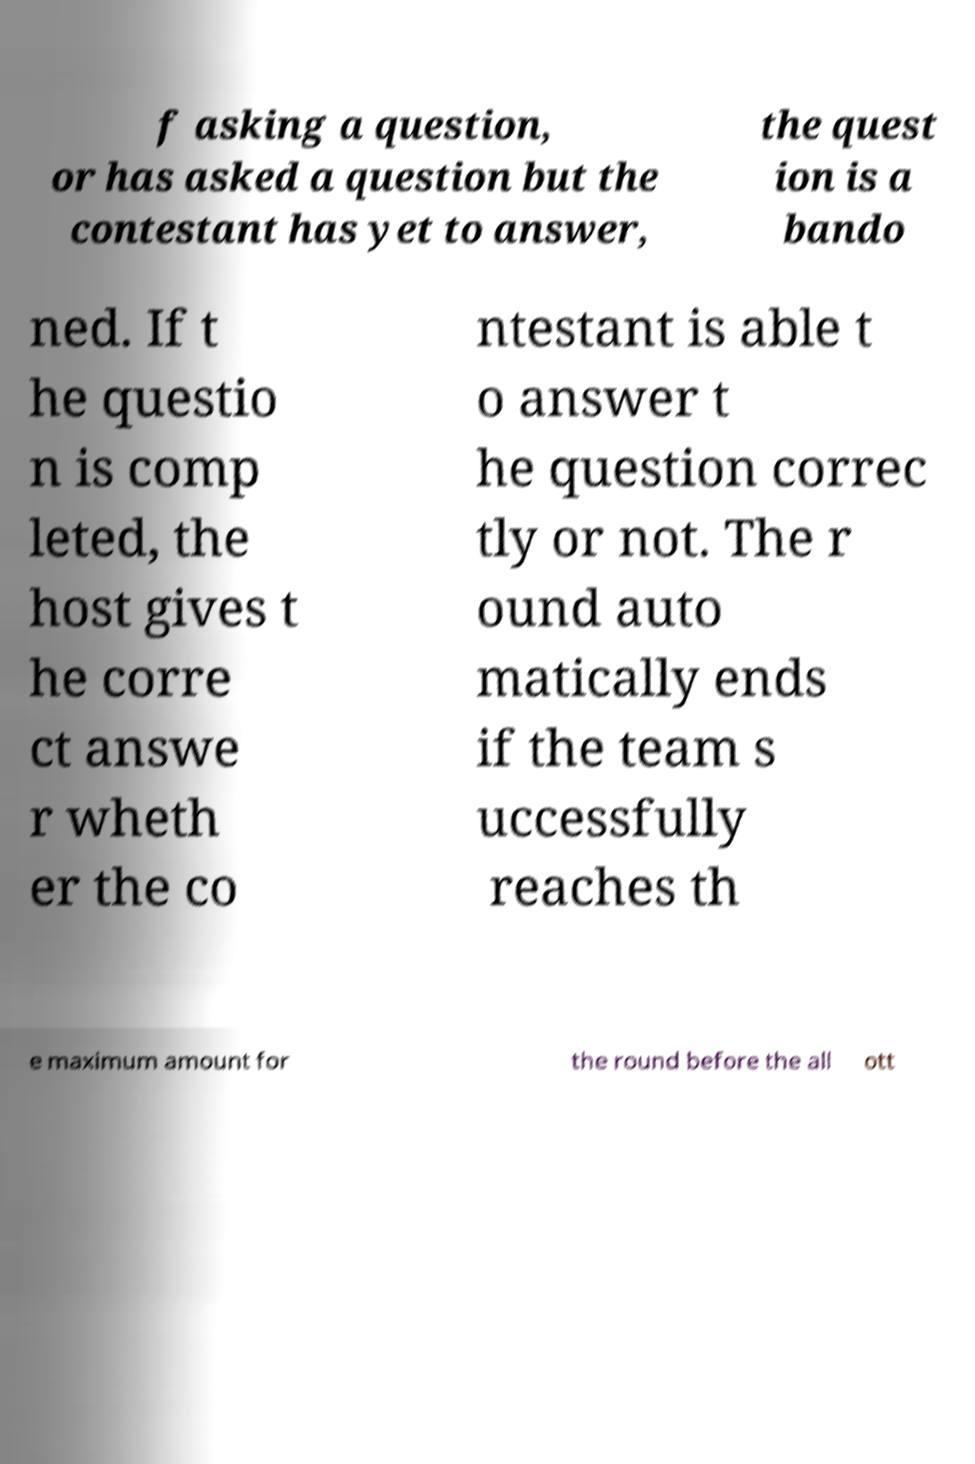Can you accurately transcribe the text from the provided image for me? f asking a question, or has asked a question but the contestant has yet to answer, the quest ion is a bando ned. If t he questio n is comp leted, the host gives t he corre ct answe r wheth er the co ntestant is able t o answer t he question correc tly or not. The r ound auto matically ends if the team s uccessfully reaches th e maximum amount for the round before the all ott 